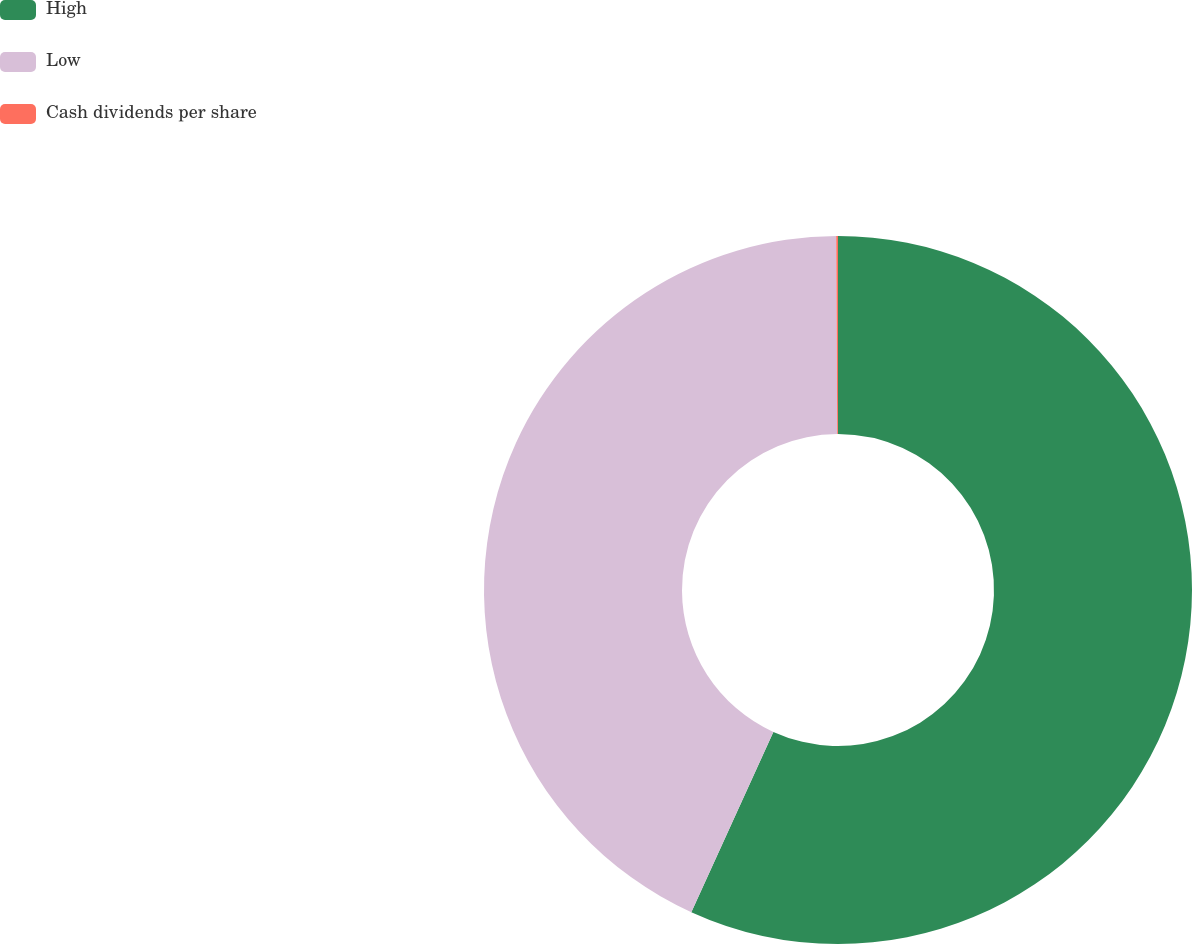<chart> <loc_0><loc_0><loc_500><loc_500><pie_chart><fcel>High<fcel>Low<fcel>Cash dividends per share<nl><fcel>56.8%<fcel>43.12%<fcel>0.08%<nl></chart> 